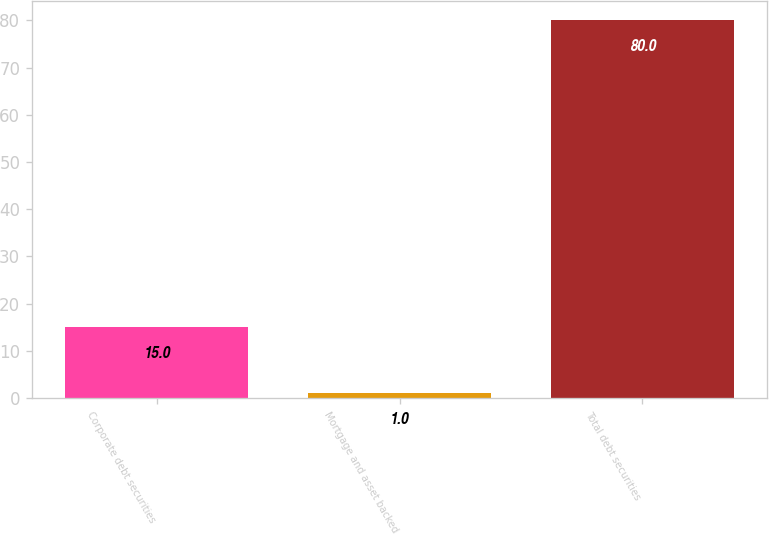Convert chart to OTSL. <chart><loc_0><loc_0><loc_500><loc_500><bar_chart><fcel>Corporate debt securities<fcel>Mortgage and asset backed<fcel>Total debt securities<nl><fcel>15<fcel>1<fcel>80<nl></chart> 